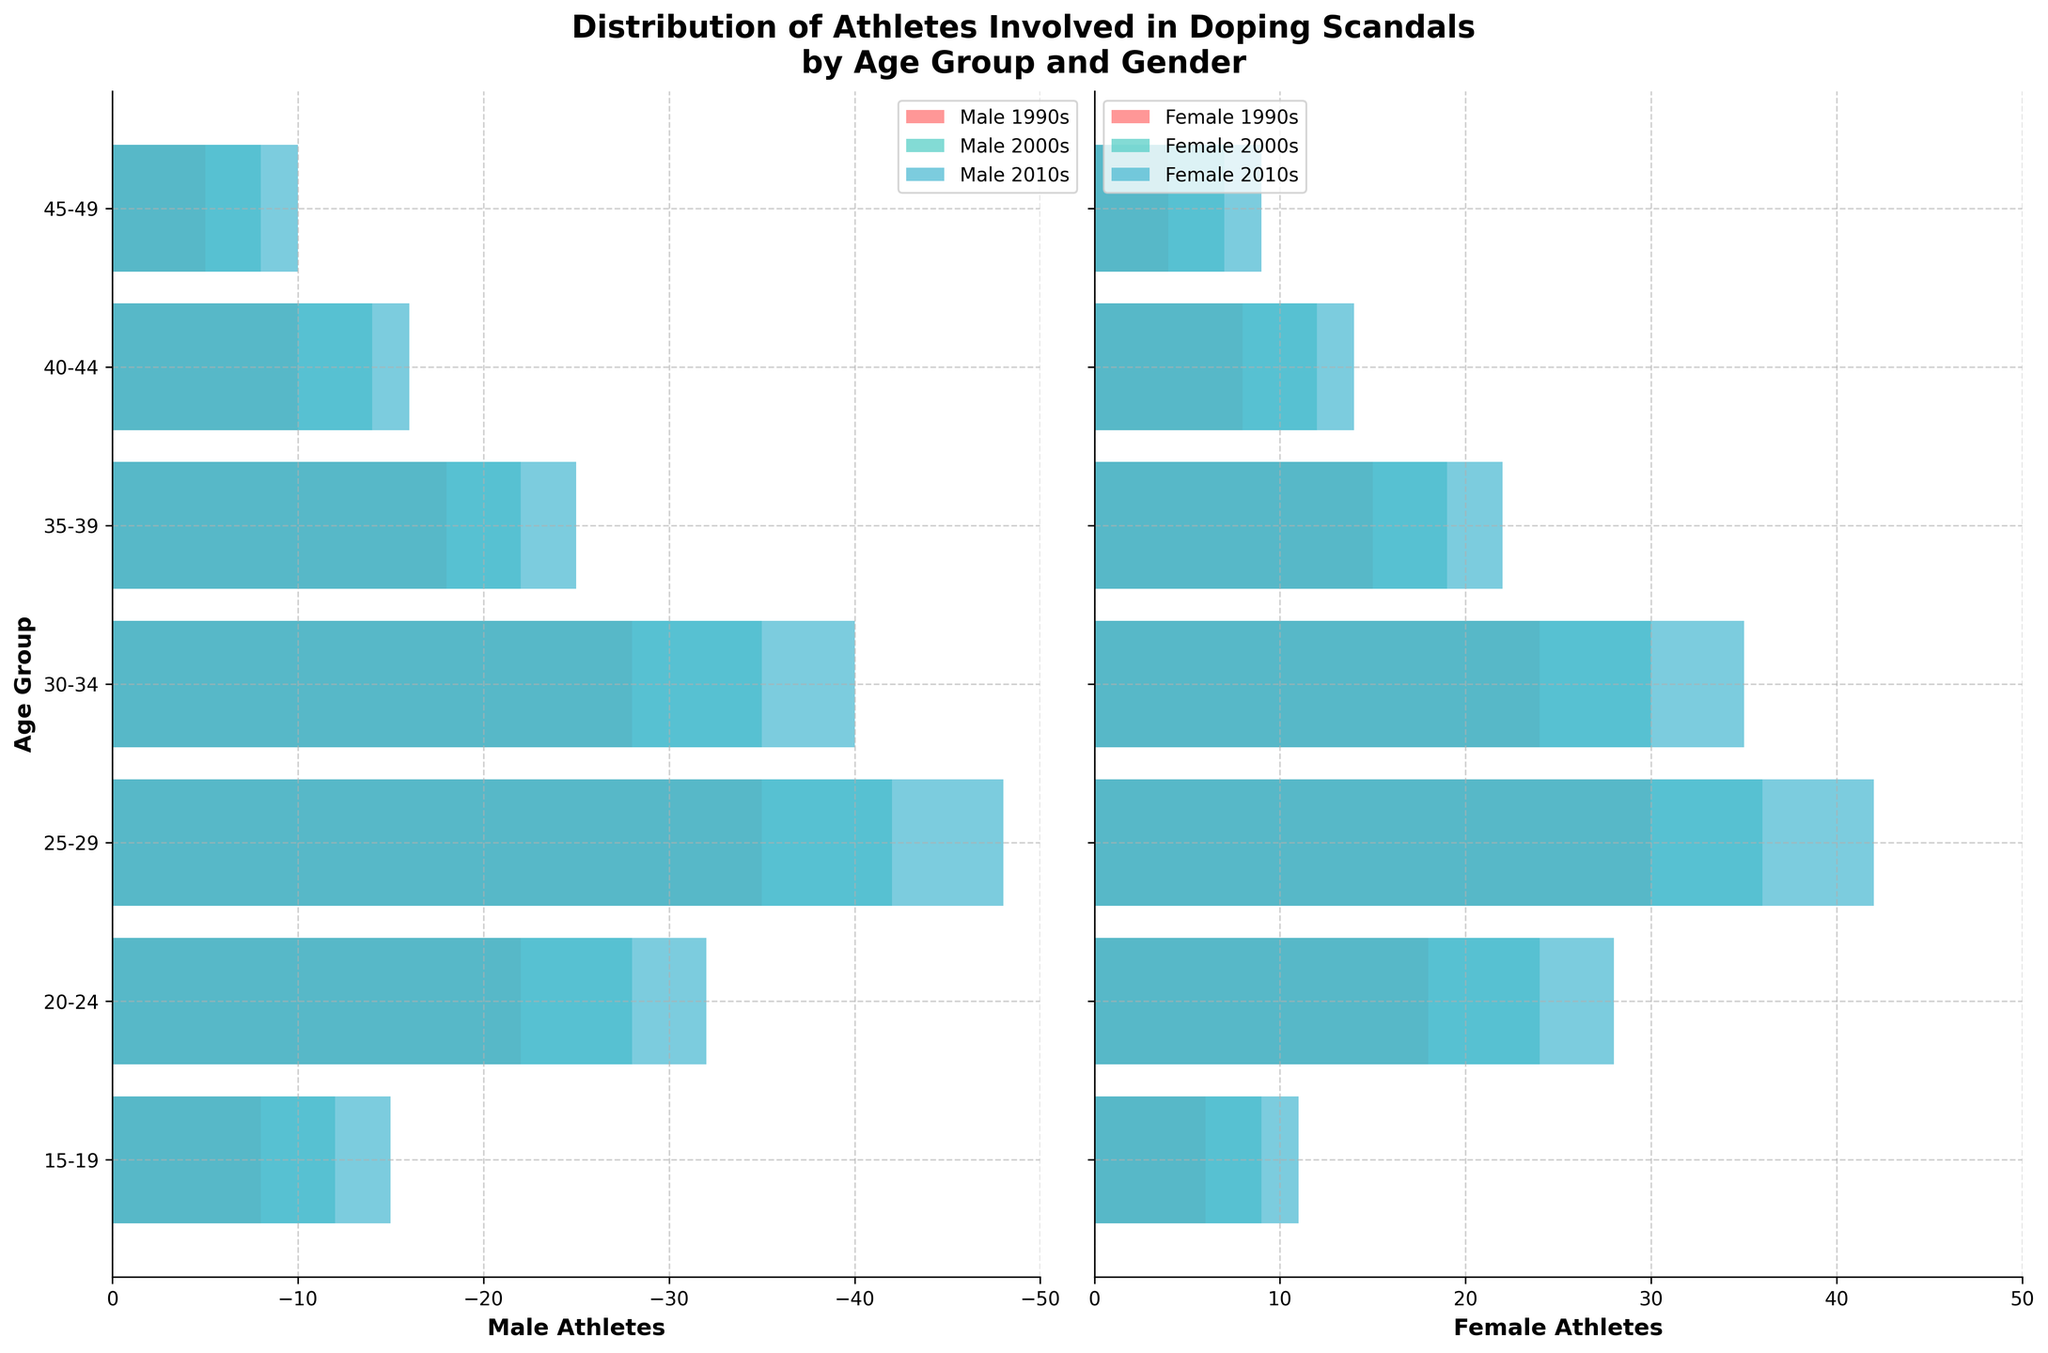What is the title of the figure? The title is usually located at the top of the figure so one needs to read it from there. The text clearly states the topic covered by the figure.
Answer: Distribution of Athletes Involved in Doping Scandals by Age Group and Gender Which age group has the highest number of male athletes involved in doping scandals in the 2010s? From the male section of the plot (on the left), observe which age group has the longest bar for the 2010s data, which is represented in blue.
Answer: 25-29 In the 2000s, which gender had the highest number of athletes involved in doping scandals for the age group 20-24? Compare the lengths of the bars for males and females in the 20-24 age group for the 2000s data. The gender with the longer bar has the highest number.
Answer: Female How does the number of female athletes involved in doping scandals in the 30-34 age group change from the 1990s to the 2010s? Compare the lengths of the bars for females in the 30-34 age group across the decades. The bars indicating positive values represent females.
Answer: Increased Which age group shows the most significant increase in the number of male athletes involved in doping scandals from the 1990s to the 2000s? Identify the difference in lengths of the male bars for each age group between the 1990s and 2000s. The age group with the largest difference shows the most significant increase.
Answer: 25-29 Do the male or female athletes in the age group 45-49 show a similar pattern across the decades? Observe the lengths of the bars for males and females in the 45-49 age group across different decades. Check if the trend (increase or decrease) over time is similar between genders.
Answer: Yes Which decade had the highest overall involvement of athletes in the age group 40-44? Compare the combined lengths of the bars (both male and female) for the 40-44 age group across the decades. The decade with the largest combined length has the highest overall involvement.
Answer: 2010s 